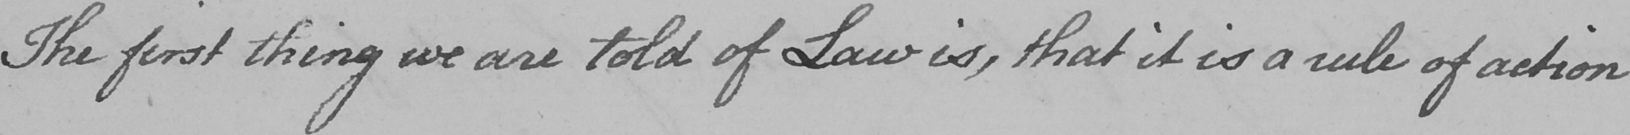Can you read and transcribe this handwriting? The first thing we are told of Law is , that it is a rule of action 